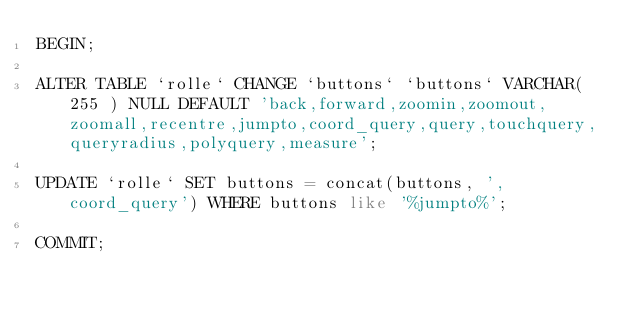Convert code to text. <code><loc_0><loc_0><loc_500><loc_500><_SQL_>BEGIN;

ALTER TABLE `rolle` CHANGE `buttons` `buttons` VARCHAR( 255 ) NULL DEFAULT 'back,forward,zoomin,zoomout,zoomall,recentre,jumpto,coord_query,query,touchquery,queryradius,polyquery,measure';

UPDATE `rolle` SET buttons = concat(buttons, ',coord_query') WHERE buttons like '%jumpto%';

COMMIT;
</code> 